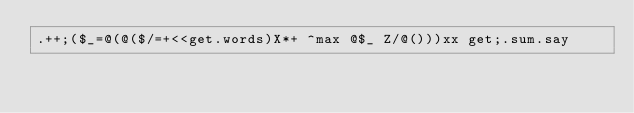Convert code to text. <code><loc_0><loc_0><loc_500><loc_500><_Perl_>.++;($_=@(@($/=+<<get.words)X*+ ^max @$_ Z/@()))xx get;.sum.say</code> 